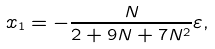Convert formula to latex. <formula><loc_0><loc_0><loc_500><loc_500>x _ { 1 } = - \frac { N } { 2 + 9 N + 7 N ^ { 2 } } \varepsilon ,</formula> 